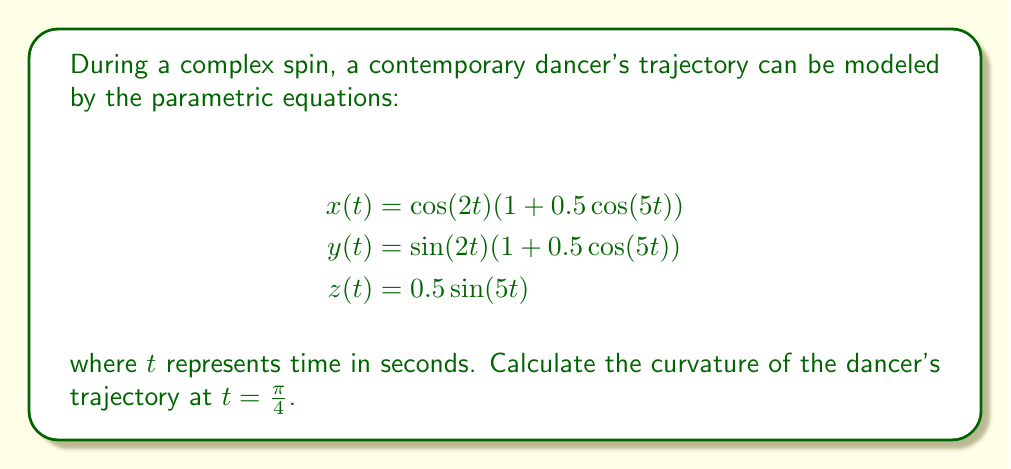Can you answer this question? To find the curvature of a space curve given by parametric equations, we use the formula:

$$\kappa = \frac{\sqrt{|\mathbf{r}'(t) \times \mathbf{r}''(t)|^2}}{|\mathbf{r}'(t)|^3}$$

Where $\mathbf{r}(t) = (x(t), y(t), z(t))$ is the position vector.

Step 1: Calculate $\mathbf{r}'(t)$
$$x'(t) = -2\sin(2t)(1 + 0.5\cos(5t)) + 0.5\cos(2t)(-5\sin(5t))$$
$$y'(t) = 2\cos(2t)(1 + 0.5\cos(5t)) + 0.5\sin(2t)(-5\sin(5t))$$
$$z'(t) = 2.5\cos(5t)$$

Step 2: Calculate $\mathbf{r}''(t)$
$$x''(t) = -4\cos(2t)(1 + 0.5\cos(5t)) + 2\sin(2t)(-5\sin(5t)) + 0.5(-2\sin(2t))(-5\sin(5t)) + 0.5\cos(2t)(-25\cos(5t))$$
$$y''(t) = -4\sin(2t)(1 + 0.5\cos(5t)) + 2\cos(2t)(-5\sin(5t)) + 0.5(2\cos(2t))(-5\sin(5t)) + 0.5\sin(2t)(-25\cos(5t))$$
$$z''(t) = -12.5\sin(5t)$$

Step 3: Evaluate $\mathbf{r}'(\frac{\pi}{4})$ and $\mathbf{r}''(\frac{\pi}{4})$
$$\mathbf{r}'(\frac{\pi}{4}) = (-\sqrt{2} - \frac{5\sqrt{2}}{4}, \sqrt{2} - \frac{5\sqrt{2}}{4}, \frac{5\sqrt{2}}{4})$$
$$\mathbf{r}''(\frac{\pi}{4}) = (-2\sqrt{2} - \frac{25\sqrt{2}}{4}, -2\sqrt{2} - \frac{25\sqrt{2}}{4}, -\frac{25\sqrt{2}}{4})$$

Step 4: Calculate $\mathbf{r}'(\frac{\pi}{4}) \times \mathbf{r}''(\frac{\pi}{4})$
$$\mathbf{r}'(\frac{\pi}{4}) \times \mathbf{r}''(\frac{\pi}{4}) = \begin{vmatrix}
\mathbf{i} & \mathbf{j} & \mathbf{k} \\
-\sqrt{2} - \frac{5\sqrt{2}}{4} & \sqrt{2} - \frac{5\sqrt{2}}{4} & \frac{5\sqrt{2}}{4} \\
-2\sqrt{2} - \frac{25\sqrt{2}}{4} & -2\sqrt{2} - \frac{25\sqrt{2}}{4} & -\frac{25\sqrt{2}}{4}
\end{vmatrix}$$

Step 5: Calculate $|\mathbf{r}'(\frac{\pi}{4}) \times \mathbf{r}''(\frac{\pi}{4})|^2$
After simplification, we get:
$$|\mathbf{r}'(\frac{\pi}{4}) \times \mathbf{r}''(\frac{\pi}{4})|^2 = \frac{2401}{8}$$

Step 6: Calculate $|\mathbf{r}'(\frac{\pi}{4})|^3$
$$|\mathbf{r}'(\frac{\pi}{4})|^3 = ((\sqrt{2} + \frac{5\sqrt{2}}{4})^2 + (\sqrt{2} - \frac{5\sqrt{2}}{4})^2 + (\frac{5\sqrt{2}}{4})^2)^{\frac{3}{2}} = (\frac{49}{8})^{\frac{3}{2}}$$

Step 7: Calculate the curvature
$$\kappa = \frac{\sqrt{\frac{2401}{8}}}{(\frac{49}{8})^{\frac{3}{2}}} = \frac{7}{7} = 1$$

Therefore, the curvature of the dancer's trajectory at $t = \frac{\pi}{4}$ is 1.
Answer: 1 